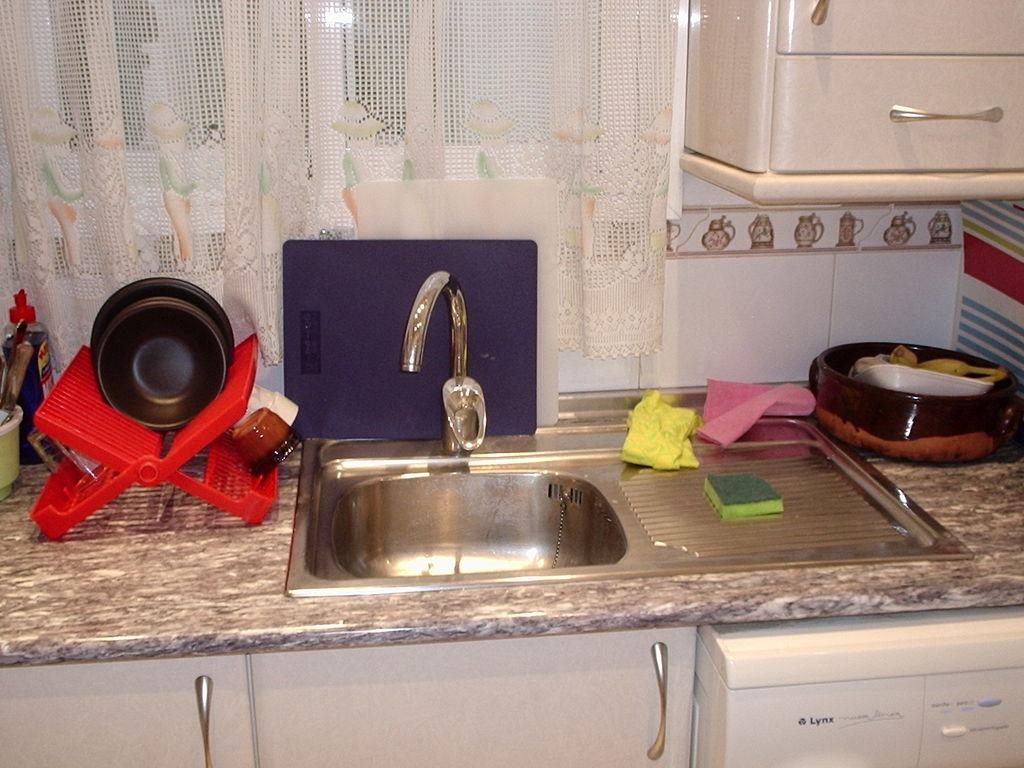<image>
Provide a brief description of the given image. The white dishwasher is manufactured by the Lynx company. 